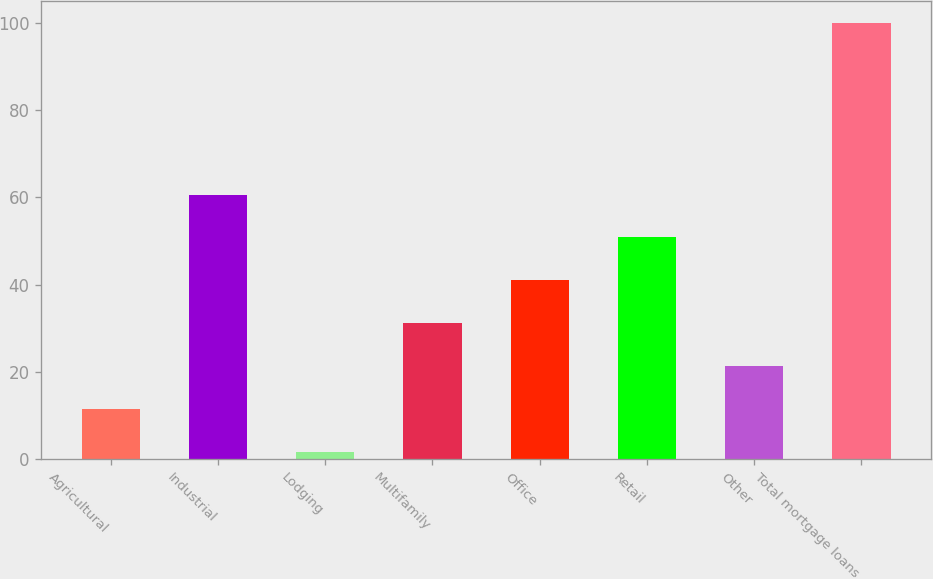Convert chart to OTSL. <chart><loc_0><loc_0><loc_500><loc_500><bar_chart><fcel>Agricultural<fcel>Industrial<fcel>Lodging<fcel>Multifamily<fcel>Office<fcel>Retail<fcel>Other<fcel>Total mortgage loans<nl><fcel>11.44<fcel>60.64<fcel>1.6<fcel>31.12<fcel>40.96<fcel>50.8<fcel>21.28<fcel>100<nl></chart> 